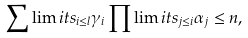<formula> <loc_0><loc_0><loc_500><loc_500>\sum \lim i t s _ { i \leq l } \gamma _ { i } \prod \lim i t s _ { j \leq i } \alpha _ { j } \leq n ,</formula> 